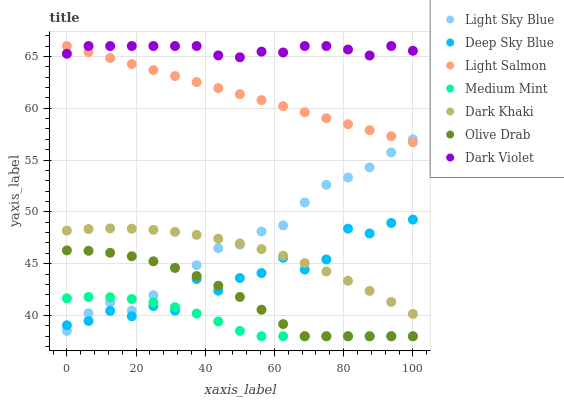Does Medium Mint have the minimum area under the curve?
Answer yes or no. Yes. Does Dark Violet have the maximum area under the curve?
Answer yes or no. Yes. Does Light Salmon have the minimum area under the curve?
Answer yes or no. No. Does Light Salmon have the maximum area under the curve?
Answer yes or no. No. Is Light Salmon the smoothest?
Answer yes or no. Yes. Is Deep Sky Blue the roughest?
Answer yes or no. Yes. Is Dark Violet the smoothest?
Answer yes or no. No. Is Dark Violet the roughest?
Answer yes or no. No. Does Medium Mint have the lowest value?
Answer yes or no. Yes. Does Light Salmon have the lowest value?
Answer yes or no. No. Does Dark Violet have the highest value?
Answer yes or no. Yes. Does Dark Khaki have the highest value?
Answer yes or no. No. Is Medium Mint less than Dark Violet?
Answer yes or no. Yes. Is Light Salmon greater than Dark Khaki?
Answer yes or no. Yes. Does Olive Drab intersect Deep Sky Blue?
Answer yes or no. Yes. Is Olive Drab less than Deep Sky Blue?
Answer yes or no. No. Is Olive Drab greater than Deep Sky Blue?
Answer yes or no. No. Does Medium Mint intersect Dark Violet?
Answer yes or no. No. 